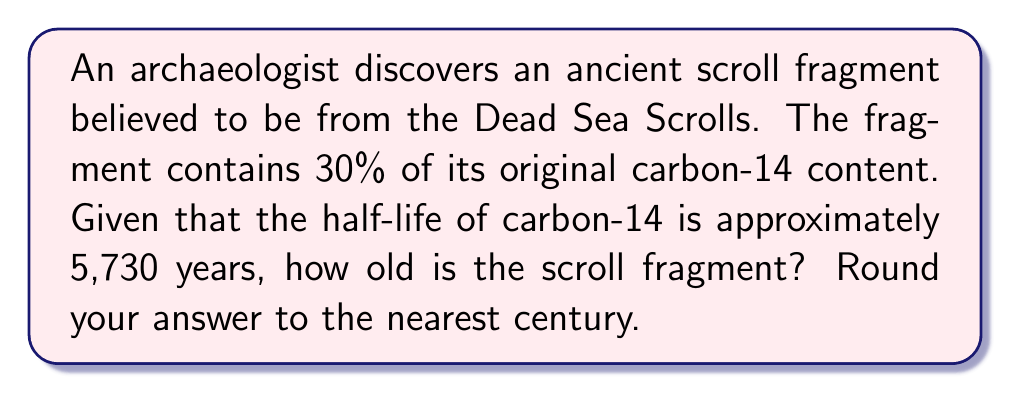Provide a solution to this math problem. To solve this problem, we'll use the exponential decay formula and the properties of logarithms. Let's approach this step-by-step:

1) The exponential decay formula is:

   $$N(t) = N_0 \cdot e^{-\lambda t}$$

   where $N(t)$ is the amount remaining after time $t$, $N_0$ is the initial amount, and $\lambda$ is the decay constant.

2) We're given that 30% of the original carbon-14 remains, so:

   $$\frac{N(t)}{N_0} = 0.30$$

3) The decay constant $\lambda$ is related to the half-life $T_{1/2}$ by:

   $$\lambda = \frac{\ln(2)}{T_{1/2}}$$

4) Substituting these into our exponential decay formula:

   $$0.30 = e^{-\frac{\ln(2)}{5730} \cdot t}$$

5) Taking the natural log of both sides:

   $$\ln(0.30) = -\frac{\ln(2)}{5730} \cdot t$$

6) Solving for $t$:

   $$t = -\frac{5730 \cdot \ln(0.30)}{\ln(2)}$$

7) Calculating this:

   $$t \approx 9983.7 \text{ years}$$

8) Rounding to the nearest century:

   $$t \approx 10,000 \text{ years}$$
Answer: 10,000 years 